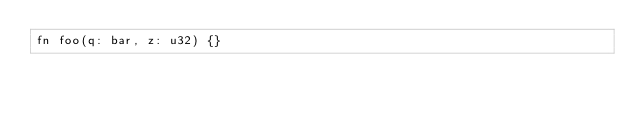<code> <loc_0><loc_0><loc_500><loc_500><_Prolog_>fn foo(q: bar, z: u32) {}</code> 